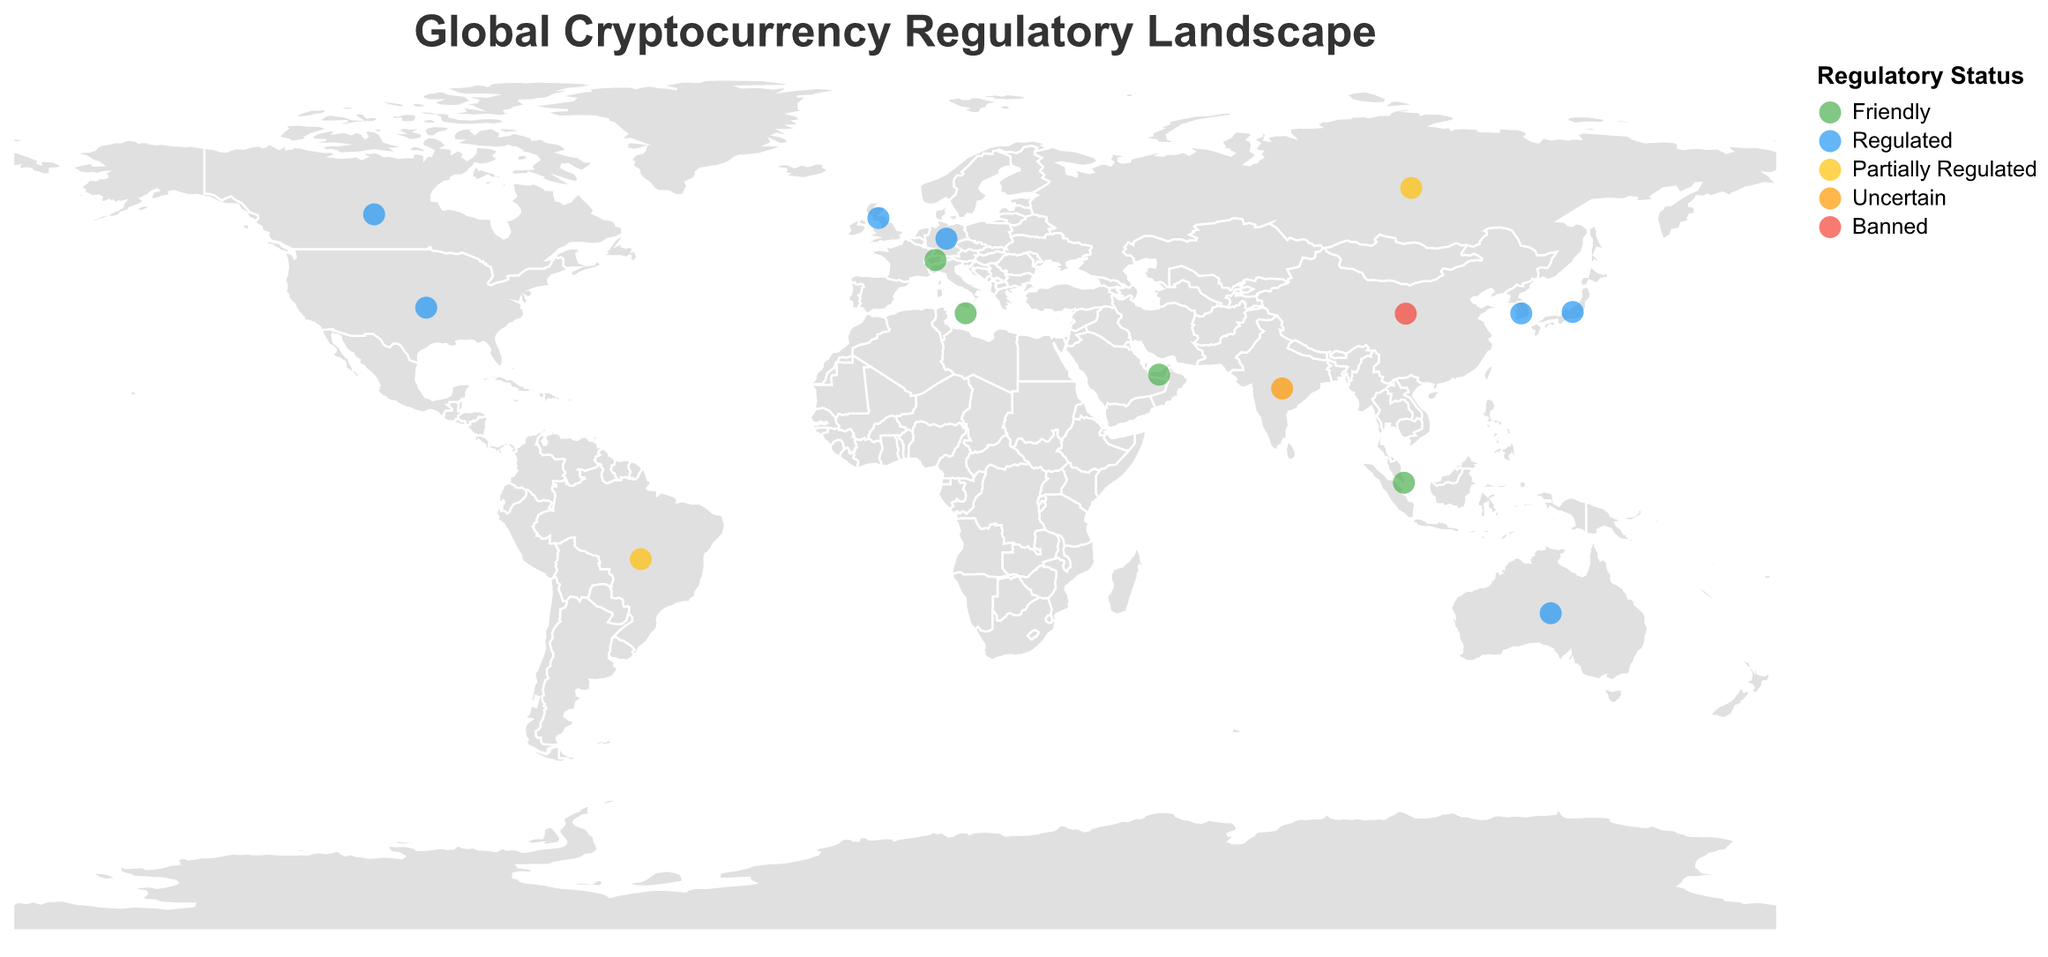Which country has the strictest trading restrictions and bans cryptocurrency mining completely? China is marked with the regulatory status of "Banned" and has "Illegal" mining legality and "Strict" trading restrictions.
Answer: China Which countries have a "Friendly" regulatory status? The countries marked with "Friendly" regulatory status are highlighted in green. They are Switzerland, Singapore, UAE, and Malta.
Answer: Switzerland, Singapore, UAE, Malta How many countries have high taxation levels on cryptocurrencies? There are three countries with a high taxation level: the United States, South Korea, and Australia, as indicated by their respective tooltips highlighted with "High" in Taxation Level.
Answer: 3 Which countries have partially regulated cryptocurrency markets? The countries with "Partially Regulated" status, colored in yellow, are Russia and Brazil.
Answer: Russia, Brazil What is the most common mining legality status among the countries shown? By observing the tooltips, almost all countries except China have "Legal" as their mining legality status.
Answer: Legal Compare trading restrictions between Japan and South Korea. Which country has higher trading restrictions? South Korea has "Moderate" trading restrictions, whereas Japan has "Low" trading restrictions. Therefore, South Korea has higher trading restrictions.
Answer: South Korea Which country has an "Uncertain" regulatory status, and what are its trading restrictions? India is marked with "Uncertain" regulatory status, and it shows "High" trading restrictions in its tooltip.
Answer: India Identify the country with "Illegal" mining legality. The only country with "Illegal" mining legality is China, as highlighted in the tooltip.
Answer: China What is the relationship between regulatory status and taxation level in the UK and Germany? Both the UK and Germany have "Regulated" regulatory status and "Moderate" taxation levels, indicating a consistency in regulatory stance and taxation.
Answer: "Regulated" and "Moderate" Which country has the highest latitude among the countries with a "Friendly" regulatory status? By inspecting the coordinates, Switzerland (46.8182° N) has the highest latitude among the "Friendly" regulatory status countries.
Answer: Switzerland 